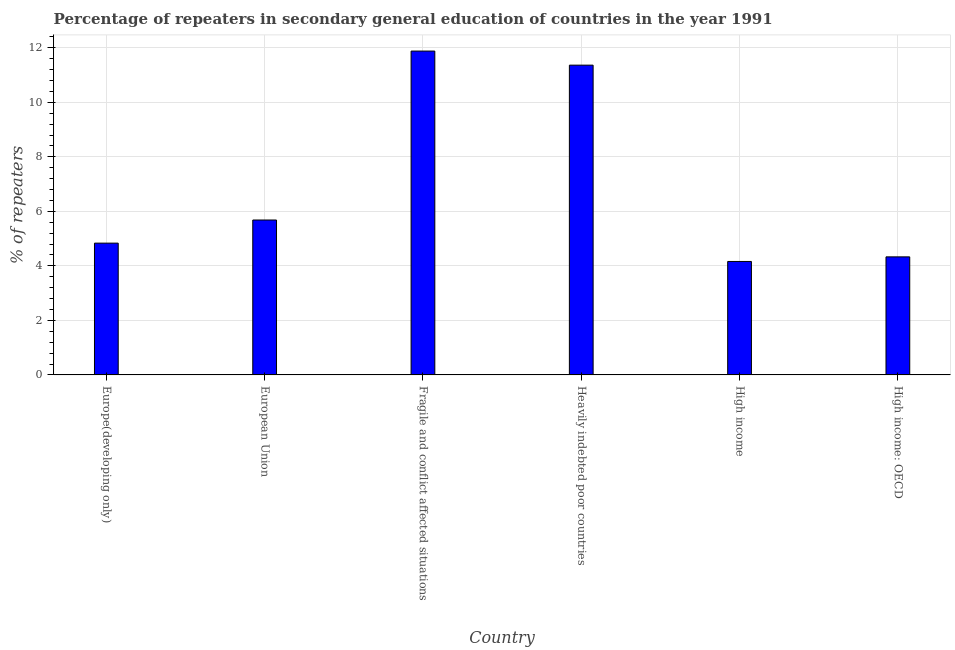What is the title of the graph?
Ensure brevity in your answer.  Percentage of repeaters in secondary general education of countries in the year 1991. What is the label or title of the Y-axis?
Your response must be concise. % of repeaters. What is the percentage of repeaters in Fragile and conflict affected situations?
Make the answer very short. 11.88. Across all countries, what is the maximum percentage of repeaters?
Your answer should be compact. 11.88. Across all countries, what is the minimum percentage of repeaters?
Provide a short and direct response. 4.16. In which country was the percentage of repeaters maximum?
Offer a very short reply. Fragile and conflict affected situations. In which country was the percentage of repeaters minimum?
Keep it short and to the point. High income. What is the sum of the percentage of repeaters?
Your response must be concise. 42.26. What is the difference between the percentage of repeaters in Fragile and conflict affected situations and Heavily indebted poor countries?
Your answer should be very brief. 0.52. What is the average percentage of repeaters per country?
Give a very brief answer. 7.04. What is the median percentage of repeaters?
Provide a short and direct response. 5.26. In how many countries, is the percentage of repeaters greater than 10.4 %?
Give a very brief answer. 2. What is the ratio of the percentage of repeaters in Fragile and conflict affected situations to that in High income: OECD?
Give a very brief answer. 2.74. Is the difference between the percentage of repeaters in Europe(developing only) and Heavily indebted poor countries greater than the difference between any two countries?
Ensure brevity in your answer.  No. What is the difference between the highest and the second highest percentage of repeaters?
Provide a short and direct response. 0.52. What is the difference between the highest and the lowest percentage of repeaters?
Your answer should be very brief. 7.72. In how many countries, is the percentage of repeaters greater than the average percentage of repeaters taken over all countries?
Give a very brief answer. 2. Are all the bars in the graph horizontal?
Your answer should be very brief. No. How many countries are there in the graph?
Offer a very short reply. 6. What is the % of repeaters of Europe(developing only)?
Your answer should be very brief. 4.83. What is the % of repeaters in European Union?
Your answer should be compact. 5.68. What is the % of repeaters in Fragile and conflict affected situations?
Your response must be concise. 11.88. What is the % of repeaters of Heavily indebted poor countries?
Your response must be concise. 11.36. What is the % of repeaters in High income?
Offer a very short reply. 4.16. What is the % of repeaters of High income: OECD?
Ensure brevity in your answer.  4.33. What is the difference between the % of repeaters in Europe(developing only) and European Union?
Your answer should be compact. -0.85. What is the difference between the % of repeaters in Europe(developing only) and Fragile and conflict affected situations?
Provide a succinct answer. -7.05. What is the difference between the % of repeaters in Europe(developing only) and Heavily indebted poor countries?
Your answer should be compact. -6.53. What is the difference between the % of repeaters in Europe(developing only) and High income?
Make the answer very short. 0.67. What is the difference between the % of repeaters in Europe(developing only) and High income: OECD?
Provide a succinct answer. 0.5. What is the difference between the % of repeaters in European Union and Fragile and conflict affected situations?
Your response must be concise. -6.2. What is the difference between the % of repeaters in European Union and Heavily indebted poor countries?
Provide a succinct answer. -5.68. What is the difference between the % of repeaters in European Union and High income?
Give a very brief answer. 1.52. What is the difference between the % of repeaters in European Union and High income: OECD?
Make the answer very short. 1.35. What is the difference between the % of repeaters in Fragile and conflict affected situations and Heavily indebted poor countries?
Your response must be concise. 0.52. What is the difference between the % of repeaters in Fragile and conflict affected situations and High income?
Your response must be concise. 7.72. What is the difference between the % of repeaters in Fragile and conflict affected situations and High income: OECD?
Offer a terse response. 7.55. What is the difference between the % of repeaters in Heavily indebted poor countries and High income?
Offer a terse response. 7.2. What is the difference between the % of repeaters in Heavily indebted poor countries and High income: OECD?
Your answer should be very brief. 7.03. What is the difference between the % of repeaters in High income and High income: OECD?
Make the answer very short. -0.17. What is the ratio of the % of repeaters in Europe(developing only) to that in European Union?
Keep it short and to the point. 0.85. What is the ratio of the % of repeaters in Europe(developing only) to that in Fragile and conflict affected situations?
Your answer should be very brief. 0.41. What is the ratio of the % of repeaters in Europe(developing only) to that in Heavily indebted poor countries?
Offer a terse response. 0.42. What is the ratio of the % of repeaters in Europe(developing only) to that in High income?
Make the answer very short. 1.16. What is the ratio of the % of repeaters in Europe(developing only) to that in High income: OECD?
Provide a succinct answer. 1.12. What is the ratio of the % of repeaters in European Union to that in Fragile and conflict affected situations?
Your response must be concise. 0.48. What is the ratio of the % of repeaters in European Union to that in High income?
Offer a very short reply. 1.36. What is the ratio of the % of repeaters in European Union to that in High income: OECD?
Make the answer very short. 1.31. What is the ratio of the % of repeaters in Fragile and conflict affected situations to that in Heavily indebted poor countries?
Your answer should be compact. 1.04. What is the ratio of the % of repeaters in Fragile and conflict affected situations to that in High income?
Ensure brevity in your answer.  2.85. What is the ratio of the % of repeaters in Fragile and conflict affected situations to that in High income: OECD?
Provide a short and direct response. 2.74. What is the ratio of the % of repeaters in Heavily indebted poor countries to that in High income?
Provide a succinct answer. 2.73. What is the ratio of the % of repeaters in Heavily indebted poor countries to that in High income: OECD?
Provide a short and direct response. 2.62. What is the ratio of the % of repeaters in High income to that in High income: OECD?
Provide a succinct answer. 0.96. 